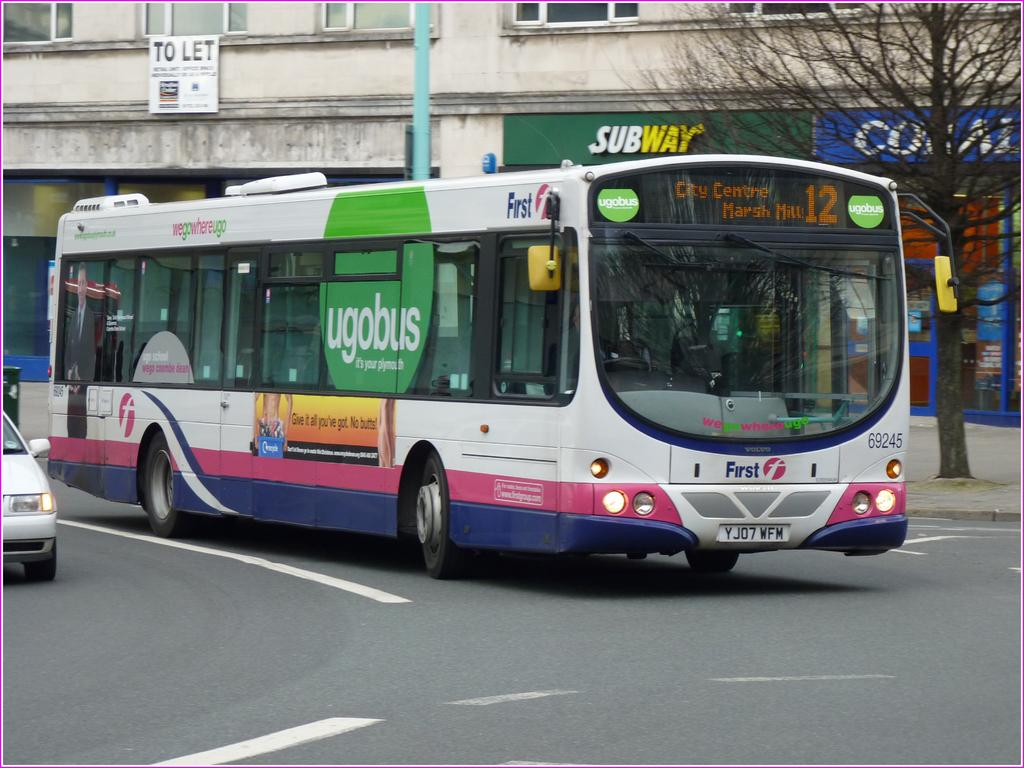Provide a one-sentence caption for the provided image. Plymoth's bus number 12 is heading into the roundabout. 